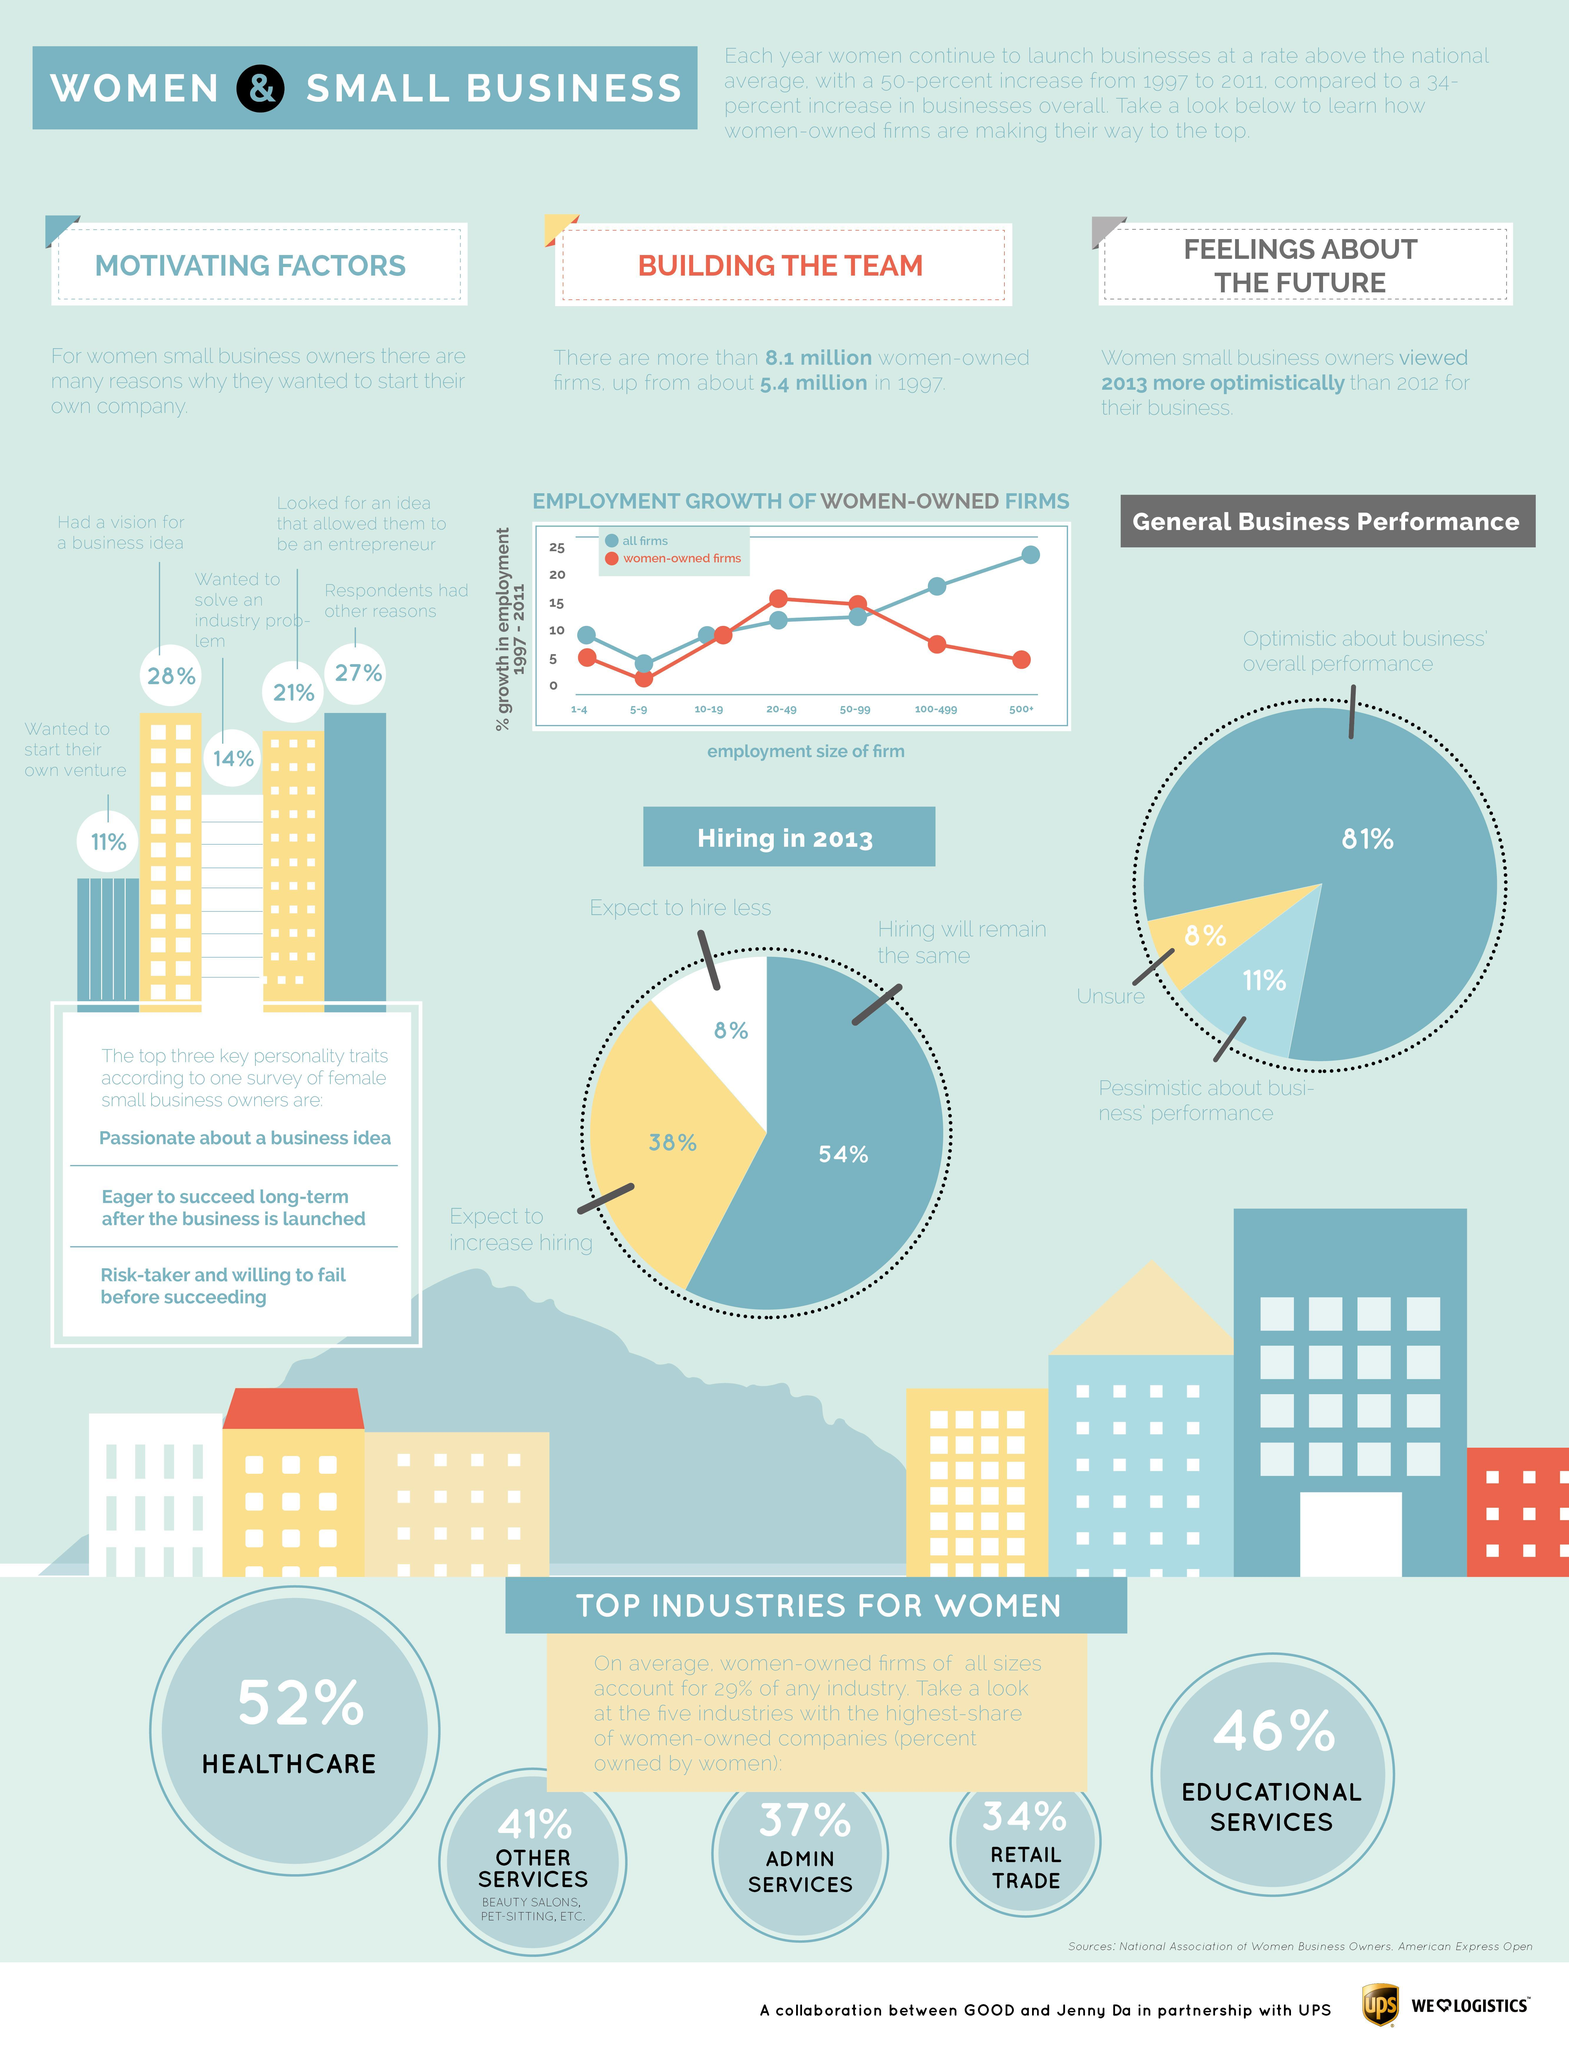What is the employment size of women-owned firms having the highest percent of growth in employment?
Answer the question with a short phrase. 20-49 How many of the women small business owners are optimistic about overall business performance? 81% In which industry is the second highest percent of women-owned companies? Educational services 52% of companies in which sector are owned by women? Healthcare What is mentioned third among the top personality traits of female business owners? Risk-taker and willing to fail before succeeding What is the top personality trait of female business owners? Passionate about a business idea For how many of the women-owned firms will hiring remain the same in 2013? 54% What percent of admin services companies are owned by women? 37% What percent of women-owned firms expect to increase hiring? 38% What was the motivating factor for 14% of women business owners to start their own company? Wanted to solve an industry problem 